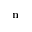<formula> <loc_0><loc_0><loc_500><loc_500>n</formula> 